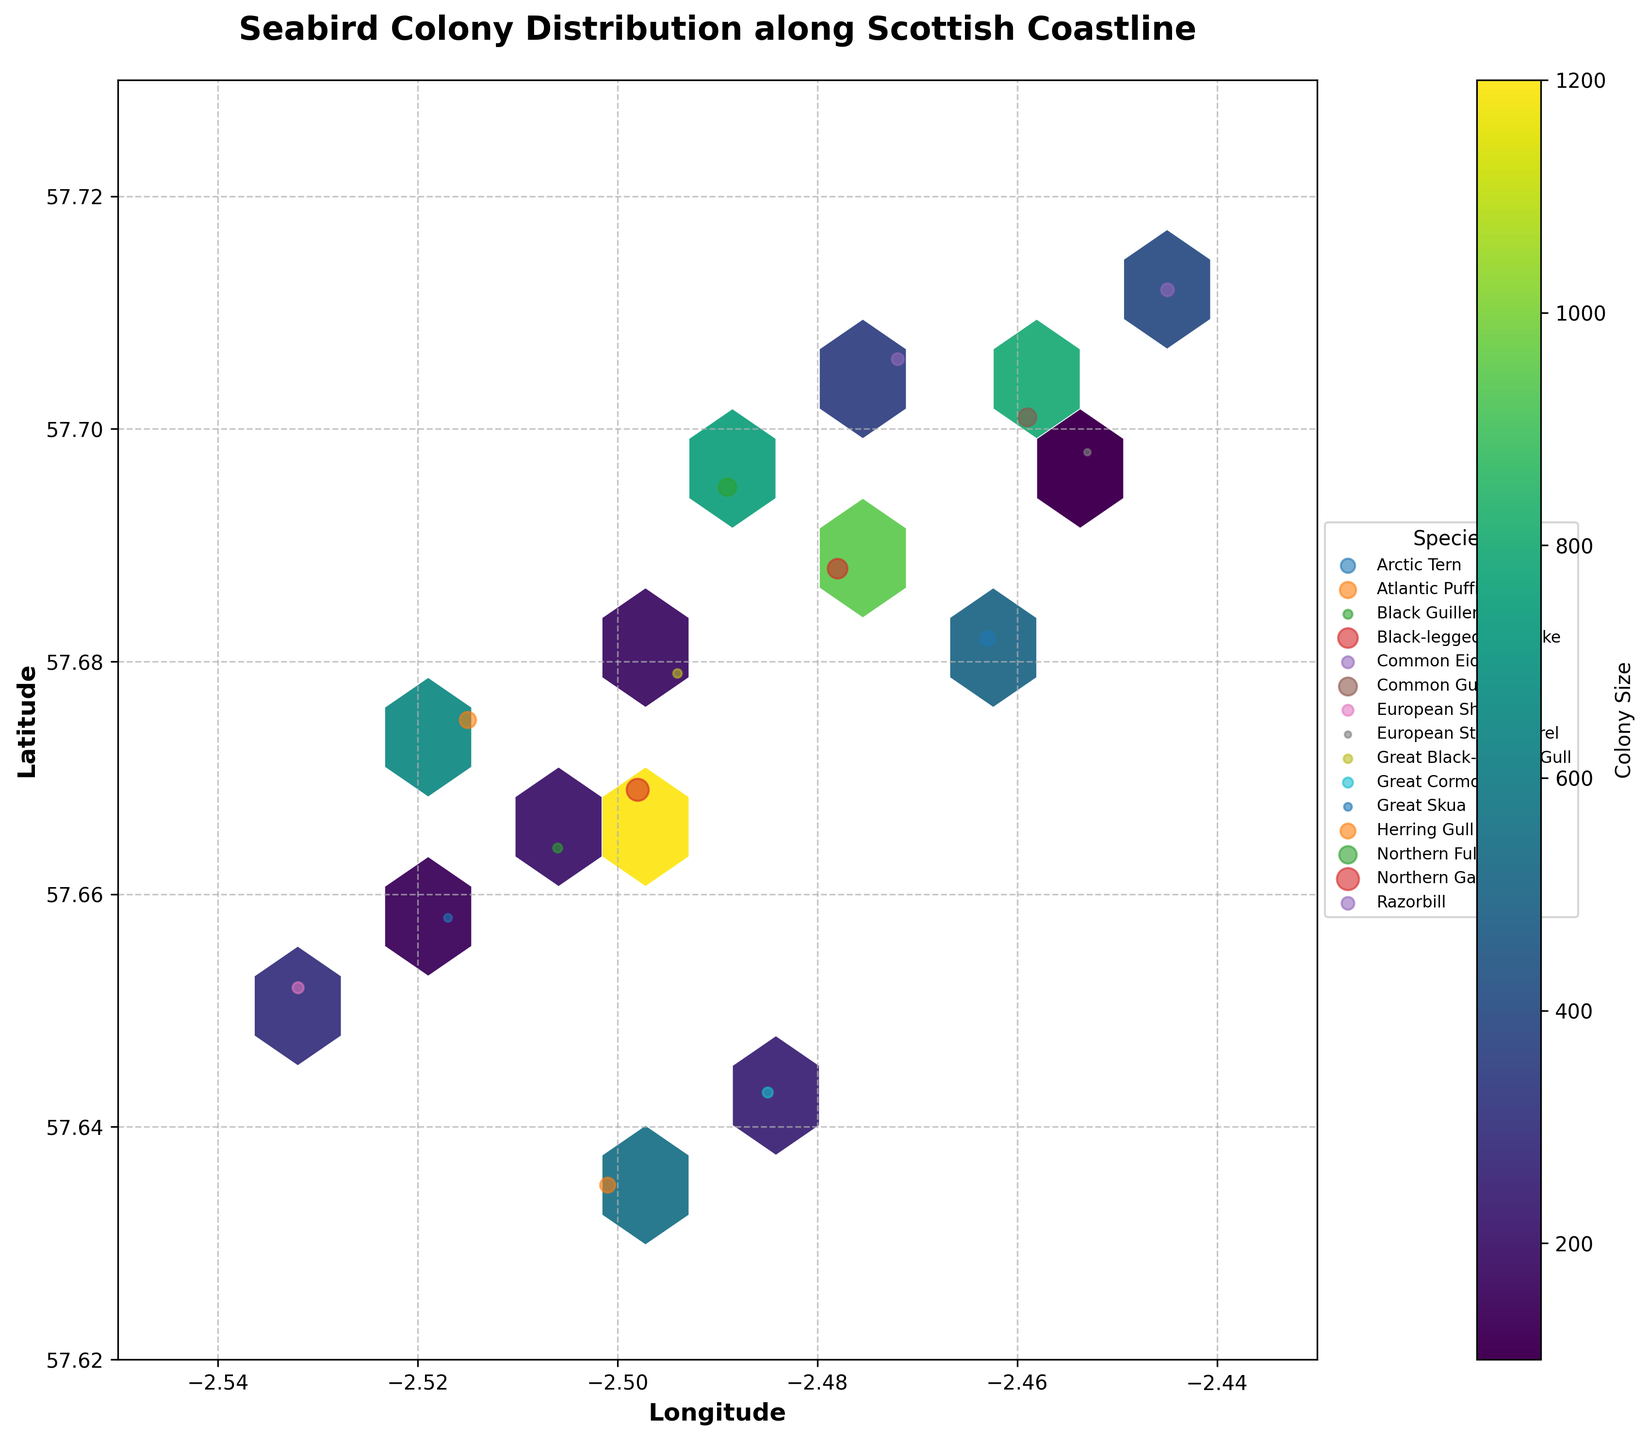What is the title of the figure? The title of the figure is usually displayed at the top of the plot. In this case, the title can be seen as "Seabird Colony Distribution along Scottish Coastline".
Answer: Seabird Colony Distribution along Scottish Coastline What are the labels for the x-axis and y-axis? The x-axis and y-axis labels are typically displayed along each axis. Here, the labels are "Longitude" for the x-axis and "Latitude" for the y-axis.
Answer: Longitude and Latitude How is the colony size represented in the hexbin plot? The colony size is shown using a color gradient, where the color intensity in each hexagon represents the colony size. This can be seen in the color bar to the right of the plot.
Answer: Color gradient Which seabird species has the largest colony size and what is its size? By checking the legend entries and referring to the size of the scatter points, the largest colony size belongs to the Northern Gannet, with a size of 1200.
Answer: Northern Gannet, 1200 How many major seabird colonies are mapped in the figure? There are multiple points representing different seabird colonies in the scatter plot, each corresponding to a species listed in the legend. Counting these points gives us the total number of colonies, which is 15.
Answer: 15 Which seabird species is found furthest north on the map? By examining the latitude values on the y-axis and the scatter points, the species closest to the highest latitude is the Razorbill.
Answer: Razorbill Do larger colonies tend to be more clustered or spread out along the coastline? By analyzing the hexbin plot, larger colony sizes (represented by darker colors) seem to be more clustered, mainly around the central regions of the map.
Answer: Clustered Which species appear to have a smaller colony size based on the scatter points, and what are their approximate sizes? The species with smaller scatter points indicate smaller colony sizes. These include the European Storm Petrel with 100 and the Great Skua with 150.
Answer: European Storm Petrel, 100; Great Skua, 150 What’s the average latitude of the seabird colonies in the dataset? To compute the average latitude, sum all latitude values and divide by the number of colonies. Summing the latitudes (57.669 + 57.701 + 57.675 + 57.688 + 57.652 + 57.635 + 57.712 + 57.695 + 57.658 + 57.682 + 57.643 + 57.706 + 57.664 + 57.698 + 57.679) and dividing by 15 gives approximately 57.68.
Answer: 57.68 Which species have colony sizes greater than 500, and where are they located? Reviewing the scatter points and the size values, species with colony sizes greater than 500 are Northern Gannet (57.669, -2.498), Common Guillemot (57.701, -2.459), Atlantic Puffin (57.675, -2.515), Black-legged Kittiwake (57.688, -2.478), Northern Fulmar (57.695, -2.489), and Herring Gull (57.635, -2.501).
Answer: Northern Gannet, Common Guillemot, Atlantic Puffin, Black-legged Kittiwake, Northern Fulmar, Herring Gull 